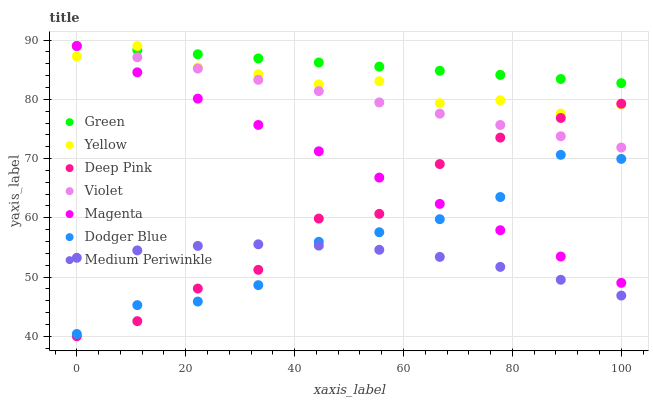Does Medium Periwinkle have the minimum area under the curve?
Answer yes or no. Yes. Does Green have the maximum area under the curve?
Answer yes or no. Yes. Does Yellow have the minimum area under the curve?
Answer yes or no. No. Does Yellow have the maximum area under the curve?
Answer yes or no. No. Is Violet the smoothest?
Answer yes or no. Yes. Is Deep Pink the roughest?
Answer yes or no. Yes. Is Medium Periwinkle the smoothest?
Answer yes or no. No. Is Medium Periwinkle the roughest?
Answer yes or no. No. Does Deep Pink have the lowest value?
Answer yes or no. Yes. Does Medium Periwinkle have the lowest value?
Answer yes or no. No. Does Magenta have the highest value?
Answer yes or no. Yes. Does Medium Periwinkle have the highest value?
Answer yes or no. No. Is Dodger Blue less than Yellow?
Answer yes or no. Yes. Is Yellow greater than Medium Periwinkle?
Answer yes or no. Yes. Does Dodger Blue intersect Medium Periwinkle?
Answer yes or no. Yes. Is Dodger Blue less than Medium Periwinkle?
Answer yes or no. No. Is Dodger Blue greater than Medium Periwinkle?
Answer yes or no. No. Does Dodger Blue intersect Yellow?
Answer yes or no. No. 